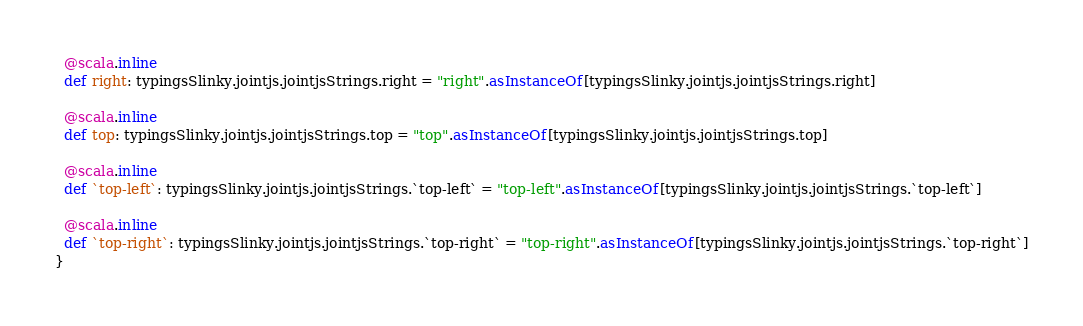Convert code to text. <code><loc_0><loc_0><loc_500><loc_500><_Scala_>  @scala.inline
  def right: typingsSlinky.jointjs.jointjsStrings.right = "right".asInstanceOf[typingsSlinky.jointjs.jointjsStrings.right]
  
  @scala.inline
  def top: typingsSlinky.jointjs.jointjsStrings.top = "top".asInstanceOf[typingsSlinky.jointjs.jointjsStrings.top]
  
  @scala.inline
  def `top-left`: typingsSlinky.jointjs.jointjsStrings.`top-left` = "top-left".asInstanceOf[typingsSlinky.jointjs.jointjsStrings.`top-left`]
  
  @scala.inline
  def `top-right`: typingsSlinky.jointjs.jointjsStrings.`top-right` = "top-right".asInstanceOf[typingsSlinky.jointjs.jointjsStrings.`top-right`]
}
</code> 